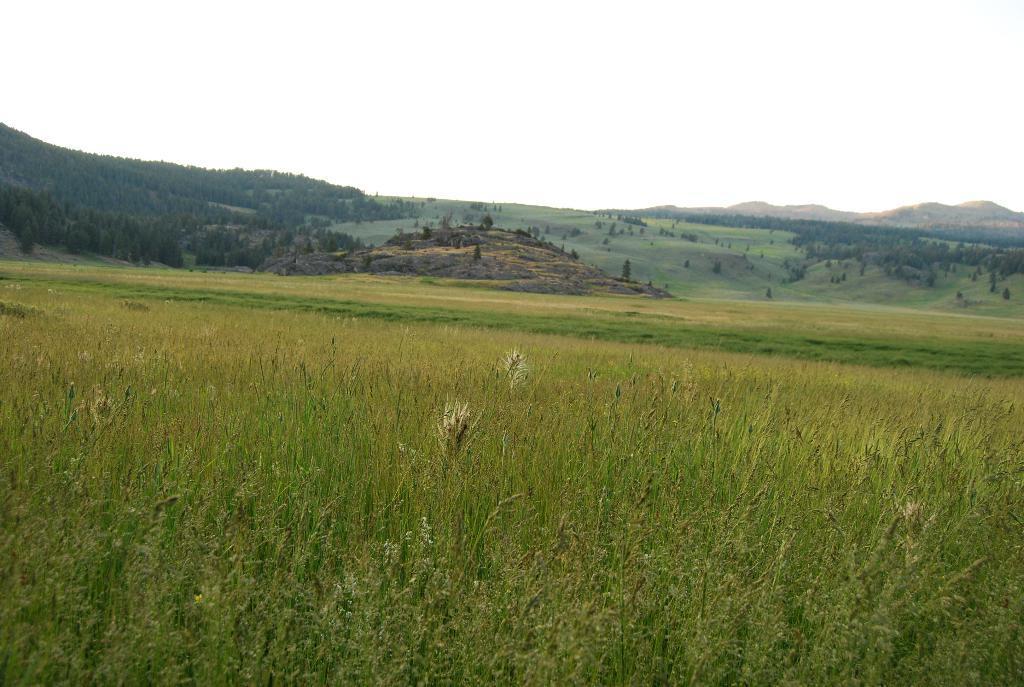In one or two sentences, can you explain what this image depicts? In the image I can see the grass, trees and some other objects on the ground. In the background I can see mountains and the sky. 